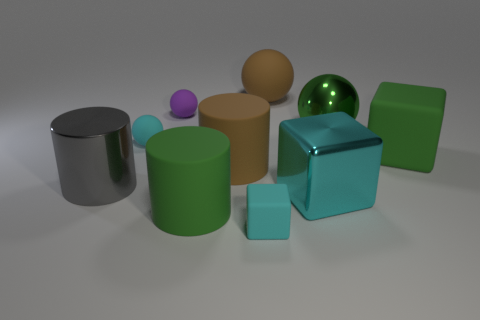Do the metal cylinder and the large matte sphere have the same color?
Make the answer very short. No. There is a big block that is the same color as the small cube; what is it made of?
Offer a very short reply. Metal. What is the color of the metal ball?
Ensure brevity in your answer.  Green. Do the green cube and the big object that is in front of the large cyan metal cube have the same material?
Ensure brevity in your answer.  Yes. How many matte objects are behind the metal cylinder and on the right side of the tiny purple rubber sphere?
Provide a succinct answer. 3. What shape is the cyan shiny thing that is the same size as the green metallic object?
Keep it short and to the point. Cube. There is a matte block in front of the cube behind the brown cylinder; are there any big gray things that are right of it?
Offer a very short reply. No. Do the big matte cube and the big matte cylinder in front of the shiny block have the same color?
Your answer should be compact. Yes. What number of tiny rubber spheres have the same color as the small block?
Your answer should be compact. 1. What size is the cyan matte thing that is right of the small purple rubber thing left of the large metallic sphere?
Your response must be concise. Small. 